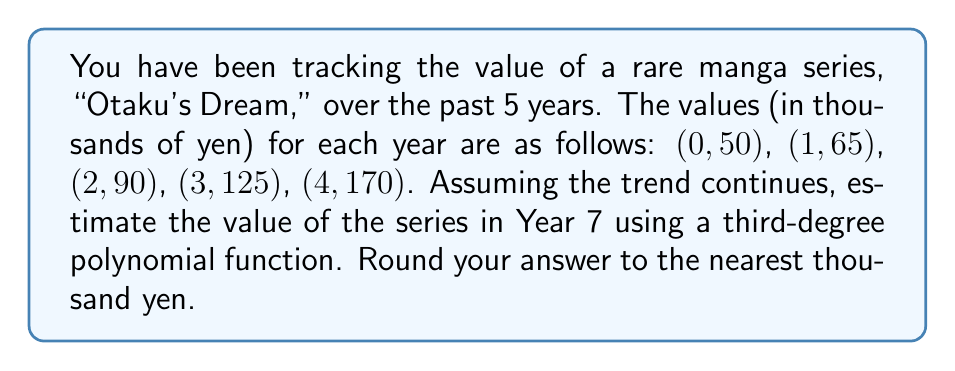Can you answer this question? To solve this problem, we'll use polynomial regression to find a third-degree polynomial that fits the given data points, then use that polynomial to estimate the value in Year 7.

1. Let's define our polynomial function as:
   $$f(x) = ax^3 + bx^2 + cx + d$$

2. We need to solve a system of equations using the given data points:
   $$50 = d$$
   $$65 = a + b + c + d$$
   $$90 = 8a + 4b + 2c + d$$
   $$125 = 27a + 9b + 3c + d$$
   $$170 = 64a + 16b + 4c + d$$

3. Subtracting the first equation from the others:
   $$15 = a + b + c$$
   $$40 = 8a + 4b + 2c$$
   $$75 = 27a + 9b + 3c$$
   $$120 = 64a + 16b + 4c$$

4. Solving this system of equations (you can use a computer algebra system or matrix methods), we get:
   $$a = 1.25$$
   $$b = 3.75$$
   $$c = 8.75$$
   $$d = 50$$

5. Our polynomial function is:
   $$f(x) = 1.25x^3 + 3.75x^2 + 8.75x + 50$$

6. To estimate the value in Year 7, we evaluate $f(7)$:
   $$f(7) = 1.25(7^3) + 3.75(7^2) + 8.75(7) + 50$$
   $$= 428.75 + 183.75 + 61.25 + 50$$
   $$= 723.75$$

7. Rounding to the nearest thousand yen:
   $$723.75 \approx 724$$

Therefore, the estimated value of the "Otaku's Dream" manga series in Year 7 is 724,000 yen.
Answer: 724,000 yen 